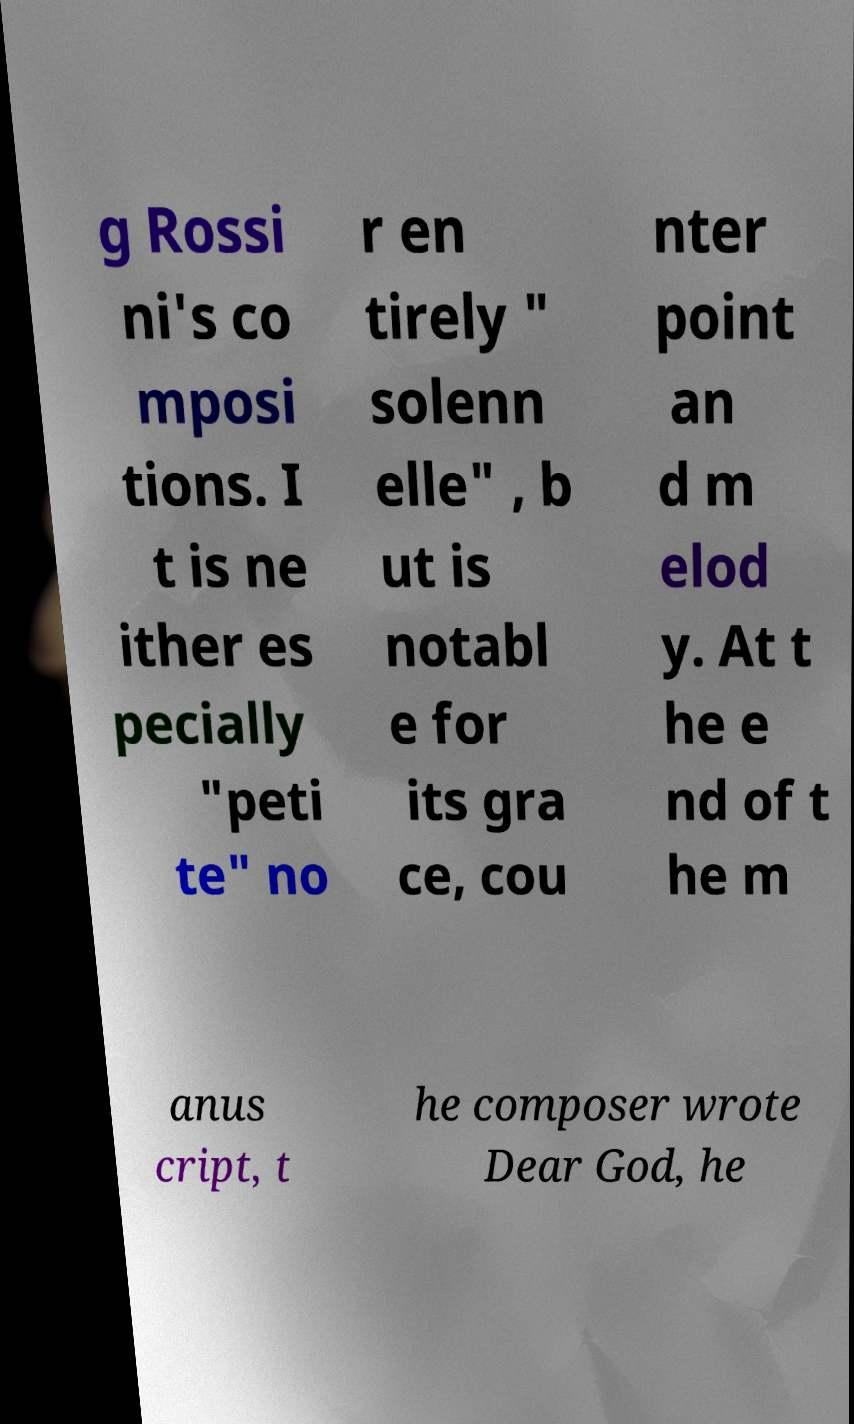Please identify and transcribe the text found in this image. g Rossi ni's co mposi tions. I t is ne ither es pecially "peti te" no r en tirely " solenn elle" , b ut is notabl e for its gra ce, cou nter point an d m elod y. At t he e nd of t he m anus cript, t he composer wrote Dear God, he 